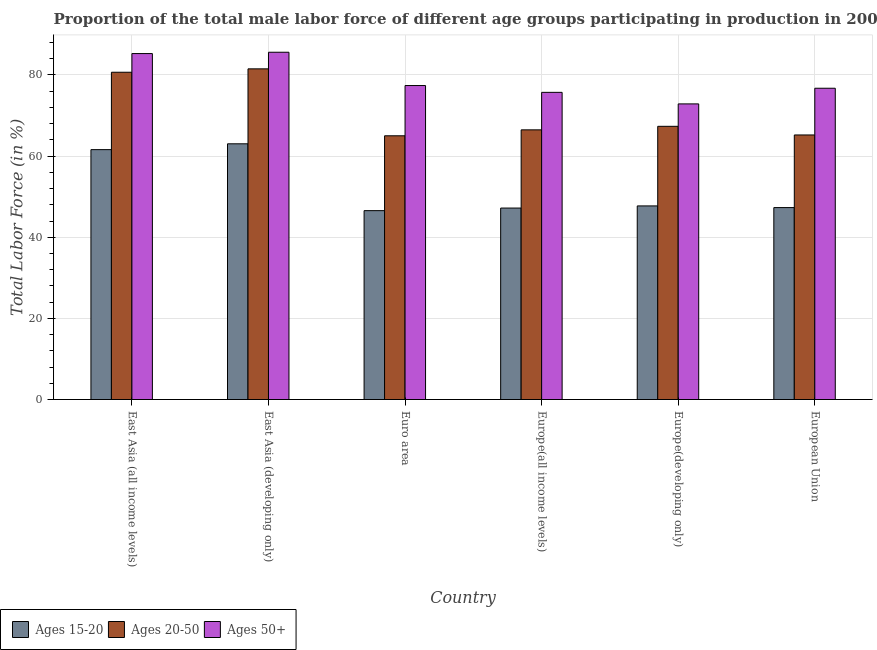How many different coloured bars are there?
Give a very brief answer. 3. How many groups of bars are there?
Offer a very short reply. 6. How many bars are there on the 3rd tick from the left?
Your answer should be very brief. 3. How many bars are there on the 6th tick from the right?
Make the answer very short. 3. What is the label of the 5th group of bars from the left?
Make the answer very short. Europe(developing only). What is the percentage of male labor force above age 50 in Europe(all income levels)?
Make the answer very short. 75.72. Across all countries, what is the maximum percentage of male labor force within the age group 15-20?
Your response must be concise. 63.04. Across all countries, what is the minimum percentage of male labor force within the age group 15-20?
Your answer should be compact. 46.56. In which country was the percentage of male labor force within the age group 15-20 maximum?
Keep it short and to the point. East Asia (developing only). In which country was the percentage of male labor force above age 50 minimum?
Offer a very short reply. Europe(developing only). What is the total percentage of male labor force above age 50 in the graph?
Provide a short and direct response. 473.61. What is the difference between the percentage of male labor force above age 50 in Euro area and that in European Union?
Your response must be concise. 0.67. What is the difference between the percentage of male labor force within the age group 15-20 in East Asia (developing only) and the percentage of male labor force within the age group 20-50 in European Union?
Ensure brevity in your answer.  -2.18. What is the average percentage of male labor force within the age group 20-50 per country?
Ensure brevity in your answer.  71.04. What is the difference between the percentage of male labor force within the age group 20-50 and percentage of male labor force above age 50 in European Union?
Your answer should be compact. -11.52. In how many countries, is the percentage of male labor force within the age group 20-50 greater than 32 %?
Your answer should be compact. 6. What is the ratio of the percentage of male labor force above age 50 in East Asia (developing only) to that in Euro area?
Offer a terse response. 1.11. Is the difference between the percentage of male labor force within the age group 20-50 in East Asia (developing only) and Europe(developing only) greater than the difference between the percentage of male labor force within the age group 15-20 in East Asia (developing only) and Europe(developing only)?
Your response must be concise. No. What is the difference between the highest and the second highest percentage of male labor force within the age group 15-20?
Offer a terse response. 1.44. What is the difference between the highest and the lowest percentage of male labor force within the age group 15-20?
Your answer should be compact. 16.48. In how many countries, is the percentage of male labor force within the age group 15-20 greater than the average percentage of male labor force within the age group 15-20 taken over all countries?
Provide a short and direct response. 2. What does the 3rd bar from the left in Europe(developing only) represents?
Your response must be concise. Ages 50+. What does the 1st bar from the right in East Asia (all income levels) represents?
Offer a very short reply. Ages 50+. How many bars are there?
Keep it short and to the point. 18. How many countries are there in the graph?
Keep it short and to the point. 6. Are the values on the major ticks of Y-axis written in scientific E-notation?
Keep it short and to the point. No. How many legend labels are there?
Give a very brief answer. 3. How are the legend labels stacked?
Your response must be concise. Horizontal. What is the title of the graph?
Offer a very short reply. Proportion of the total male labor force of different age groups participating in production in 2003. What is the label or title of the X-axis?
Your answer should be very brief. Country. What is the label or title of the Y-axis?
Provide a succinct answer. Total Labor Force (in %). What is the Total Labor Force (in %) of Ages 15-20 in East Asia (all income levels)?
Your answer should be compact. 61.6. What is the Total Labor Force (in %) in Ages 20-50 in East Asia (all income levels)?
Offer a very short reply. 80.68. What is the Total Labor Force (in %) in Ages 50+ in East Asia (all income levels)?
Ensure brevity in your answer.  85.28. What is the Total Labor Force (in %) in Ages 15-20 in East Asia (developing only)?
Your response must be concise. 63.04. What is the Total Labor Force (in %) of Ages 20-50 in East Asia (developing only)?
Your response must be concise. 81.51. What is the Total Labor Force (in %) in Ages 50+ in East Asia (developing only)?
Your answer should be very brief. 85.61. What is the Total Labor Force (in %) of Ages 15-20 in Euro area?
Give a very brief answer. 46.56. What is the Total Labor Force (in %) of Ages 20-50 in Euro area?
Your answer should be compact. 65.01. What is the Total Labor Force (in %) of Ages 50+ in Euro area?
Provide a short and direct response. 77.4. What is the Total Labor Force (in %) in Ages 15-20 in Europe(all income levels)?
Your answer should be compact. 47.2. What is the Total Labor Force (in %) of Ages 20-50 in Europe(all income levels)?
Your answer should be very brief. 66.48. What is the Total Labor Force (in %) in Ages 50+ in Europe(all income levels)?
Offer a very short reply. 75.72. What is the Total Labor Force (in %) of Ages 15-20 in Europe(developing only)?
Your response must be concise. 47.72. What is the Total Labor Force (in %) of Ages 20-50 in Europe(developing only)?
Offer a very short reply. 67.35. What is the Total Labor Force (in %) of Ages 50+ in Europe(developing only)?
Provide a succinct answer. 72.87. What is the Total Labor Force (in %) in Ages 15-20 in European Union?
Give a very brief answer. 47.31. What is the Total Labor Force (in %) of Ages 20-50 in European Union?
Offer a very short reply. 65.22. What is the Total Labor Force (in %) of Ages 50+ in European Union?
Offer a very short reply. 76.73. Across all countries, what is the maximum Total Labor Force (in %) of Ages 15-20?
Offer a terse response. 63.04. Across all countries, what is the maximum Total Labor Force (in %) in Ages 20-50?
Your response must be concise. 81.51. Across all countries, what is the maximum Total Labor Force (in %) in Ages 50+?
Offer a terse response. 85.61. Across all countries, what is the minimum Total Labor Force (in %) of Ages 15-20?
Provide a succinct answer. 46.56. Across all countries, what is the minimum Total Labor Force (in %) of Ages 20-50?
Keep it short and to the point. 65.01. Across all countries, what is the minimum Total Labor Force (in %) of Ages 50+?
Offer a terse response. 72.87. What is the total Total Labor Force (in %) of Ages 15-20 in the graph?
Offer a very short reply. 313.43. What is the total Total Labor Force (in %) in Ages 20-50 in the graph?
Keep it short and to the point. 426.25. What is the total Total Labor Force (in %) in Ages 50+ in the graph?
Provide a succinct answer. 473.61. What is the difference between the Total Labor Force (in %) of Ages 15-20 in East Asia (all income levels) and that in East Asia (developing only)?
Ensure brevity in your answer.  -1.44. What is the difference between the Total Labor Force (in %) of Ages 20-50 in East Asia (all income levels) and that in East Asia (developing only)?
Your answer should be compact. -0.84. What is the difference between the Total Labor Force (in %) of Ages 50+ in East Asia (all income levels) and that in East Asia (developing only)?
Provide a short and direct response. -0.33. What is the difference between the Total Labor Force (in %) of Ages 15-20 in East Asia (all income levels) and that in Euro area?
Make the answer very short. 15.04. What is the difference between the Total Labor Force (in %) in Ages 20-50 in East Asia (all income levels) and that in Euro area?
Ensure brevity in your answer.  15.67. What is the difference between the Total Labor Force (in %) of Ages 50+ in East Asia (all income levels) and that in Euro area?
Your answer should be very brief. 7.88. What is the difference between the Total Labor Force (in %) of Ages 15-20 in East Asia (all income levels) and that in Europe(all income levels)?
Give a very brief answer. 14.4. What is the difference between the Total Labor Force (in %) in Ages 20-50 in East Asia (all income levels) and that in Europe(all income levels)?
Give a very brief answer. 14.2. What is the difference between the Total Labor Force (in %) of Ages 50+ in East Asia (all income levels) and that in Europe(all income levels)?
Offer a terse response. 9.56. What is the difference between the Total Labor Force (in %) of Ages 15-20 in East Asia (all income levels) and that in Europe(developing only)?
Provide a short and direct response. 13.87. What is the difference between the Total Labor Force (in %) of Ages 20-50 in East Asia (all income levels) and that in Europe(developing only)?
Your response must be concise. 13.33. What is the difference between the Total Labor Force (in %) in Ages 50+ in East Asia (all income levels) and that in Europe(developing only)?
Offer a very short reply. 12.41. What is the difference between the Total Labor Force (in %) of Ages 15-20 in East Asia (all income levels) and that in European Union?
Provide a succinct answer. 14.29. What is the difference between the Total Labor Force (in %) of Ages 20-50 in East Asia (all income levels) and that in European Union?
Offer a terse response. 15.46. What is the difference between the Total Labor Force (in %) of Ages 50+ in East Asia (all income levels) and that in European Union?
Provide a succinct answer. 8.55. What is the difference between the Total Labor Force (in %) in Ages 15-20 in East Asia (developing only) and that in Euro area?
Offer a terse response. 16.48. What is the difference between the Total Labor Force (in %) in Ages 20-50 in East Asia (developing only) and that in Euro area?
Offer a very short reply. 16.5. What is the difference between the Total Labor Force (in %) in Ages 50+ in East Asia (developing only) and that in Euro area?
Your answer should be very brief. 8.21. What is the difference between the Total Labor Force (in %) in Ages 15-20 in East Asia (developing only) and that in Europe(all income levels)?
Ensure brevity in your answer.  15.84. What is the difference between the Total Labor Force (in %) in Ages 20-50 in East Asia (developing only) and that in Europe(all income levels)?
Provide a succinct answer. 15.04. What is the difference between the Total Labor Force (in %) in Ages 50+ in East Asia (developing only) and that in Europe(all income levels)?
Keep it short and to the point. 9.89. What is the difference between the Total Labor Force (in %) in Ages 15-20 in East Asia (developing only) and that in Europe(developing only)?
Offer a terse response. 15.31. What is the difference between the Total Labor Force (in %) in Ages 20-50 in East Asia (developing only) and that in Europe(developing only)?
Make the answer very short. 14.17. What is the difference between the Total Labor Force (in %) of Ages 50+ in East Asia (developing only) and that in Europe(developing only)?
Your answer should be very brief. 12.74. What is the difference between the Total Labor Force (in %) of Ages 15-20 in East Asia (developing only) and that in European Union?
Offer a very short reply. 15.72. What is the difference between the Total Labor Force (in %) of Ages 20-50 in East Asia (developing only) and that in European Union?
Your response must be concise. 16.3. What is the difference between the Total Labor Force (in %) in Ages 50+ in East Asia (developing only) and that in European Union?
Provide a short and direct response. 8.88. What is the difference between the Total Labor Force (in %) in Ages 15-20 in Euro area and that in Europe(all income levels)?
Ensure brevity in your answer.  -0.64. What is the difference between the Total Labor Force (in %) in Ages 20-50 in Euro area and that in Europe(all income levels)?
Offer a terse response. -1.46. What is the difference between the Total Labor Force (in %) in Ages 50+ in Euro area and that in Europe(all income levels)?
Give a very brief answer. 1.68. What is the difference between the Total Labor Force (in %) of Ages 15-20 in Euro area and that in Europe(developing only)?
Give a very brief answer. -1.17. What is the difference between the Total Labor Force (in %) in Ages 20-50 in Euro area and that in Europe(developing only)?
Provide a short and direct response. -2.34. What is the difference between the Total Labor Force (in %) of Ages 50+ in Euro area and that in Europe(developing only)?
Offer a terse response. 4.53. What is the difference between the Total Labor Force (in %) in Ages 15-20 in Euro area and that in European Union?
Your answer should be very brief. -0.76. What is the difference between the Total Labor Force (in %) in Ages 20-50 in Euro area and that in European Union?
Keep it short and to the point. -0.21. What is the difference between the Total Labor Force (in %) in Ages 50+ in Euro area and that in European Union?
Your answer should be compact. 0.67. What is the difference between the Total Labor Force (in %) in Ages 15-20 in Europe(all income levels) and that in Europe(developing only)?
Offer a very short reply. -0.53. What is the difference between the Total Labor Force (in %) in Ages 20-50 in Europe(all income levels) and that in Europe(developing only)?
Make the answer very short. -0.87. What is the difference between the Total Labor Force (in %) in Ages 50+ in Europe(all income levels) and that in Europe(developing only)?
Make the answer very short. 2.85. What is the difference between the Total Labor Force (in %) of Ages 15-20 in Europe(all income levels) and that in European Union?
Offer a terse response. -0.12. What is the difference between the Total Labor Force (in %) of Ages 20-50 in Europe(all income levels) and that in European Union?
Make the answer very short. 1.26. What is the difference between the Total Labor Force (in %) of Ages 50+ in Europe(all income levels) and that in European Union?
Offer a terse response. -1.01. What is the difference between the Total Labor Force (in %) of Ages 15-20 in Europe(developing only) and that in European Union?
Your answer should be compact. 0.41. What is the difference between the Total Labor Force (in %) in Ages 20-50 in Europe(developing only) and that in European Union?
Make the answer very short. 2.13. What is the difference between the Total Labor Force (in %) in Ages 50+ in Europe(developing only) and that in European Union?
Your answer should be compact. -3.86. What is the difference between the Total Labor Force (in %) of Ages 15-20 in East Asia (all income levels) and the Total Labor Force (in %) of Ages 20-50 in East Asia (developing only)?
Ensure brevity in your answer.  -19.91. What is the difference between the Total Labor Force (in %) in Ages 15-20 in East Asia (all income levels) and the Total Labor Force (in %) in Ages 50+ in East Asia (developing only)?
Give a very brief answer. -24.01. What is the difference between the Total Labor Force (in %) in Ages 20-50 in East Asia (all income levels) and the Total Labor Force (in %) in Ages 50+ in East Asia (developing only)?
Ensure brevity in your answer.  -4.93. What is the difference between the Total Labor Force (in %) of Ages 15-20 in East Asia (all income levels) and the Total Labor Force (in %) of Ages 20-50 in Euro area?
Make the answer very short. -3.41. What is the difference between the Total Labor Force (in %) in Ages 15-20 in East Asia (all income levels) and the Total Labor Force (in %) in Ages 50+ in Euro area?
Provide a succinct answer. -15.8. What is the difference between the Total Labor Force (in %) in Ages 20-50 in East Asia (all income levels) and the Total Labor Force (in %) in Ages 50+ in Euro area?
Ensure brevity in your answer.  3.28. What is the difference between the Total Labor Force (in %) of Ages 15-20 in East Asia (all income levels) and the Total Labor Force (in %) of Ages 20-50 in Europe(all income levels)?
Keep it short and to the point. -4.88. What is the difference between the Total Labor Force (in %) in Ages 15-20 in East Asia (all income levels) and the Total Labor Force (in %) in Ages 50+ in Europe(all income levels)?
Your response must be concise. -14.12. What is the difference between the Total Labor Force (in %) in Ages 20-50 in East Asia (all income levels) and the Total Labor Force (in %) in Ages 50+ in Europe(all income levels)?
Your answer should be very brief. 4.96. What is the difference between the Total Labor Force (in %) in Ages 15-20 in East Asia (all income levels) and the Total Labor Force (in %) in Ages 20-50 in Europe(developing only)?
Give a very brief answer. -5.75. What is the difference between the Total Labor Force (in %) of Ages 15-20 in East Asia (all income levels) and the Total Labor Force (in %) of Ages 50+ in Europe(developing only)?
Give a very brief answer. -11.27. What is the difference between the Total Labor Force (in %) in Ages 20-50 in East Asia (all income levels) and the Total Labor Force (in %) in Ages 50+ in Europe(developing only)?
Offer a very short reply. 7.81. What is the difference between the Total Labor Force (in %) of Ages 15-20 in East Asia (all income levels) and the Total Labor Force (in %) of Ages 20-50 in European Union?
Your answer should be very brief. -3.62. What is the difference between the Total Labor Force (in %) in Ages 15-20 in East Asia (all income levels) and the Total Labor Force (in %) in Ages 50+ in European Union?
Your answer should be very brief. -15.13. What is the difference between the Total Labor Force (in %) in Ages 20-50 in East Asia (all income levels) and the Total Labor Force (in %) in Ages 50+ in European Union?
Offer a very short reply. 3.95. What is the difference between the Total Labor Force (in %) of Ages 15-20 in East Asia (developing only) and the Total Labor Force (in %) of Ages 20-50 in Euro area?
Make the answer very short. -1.98. What is the difference between the Total Labor Force (in %) of Ages 15-20 in East Asia (developing only) and the Total Labor Force (in %) of Ages 50+ in Euro area?
Your answer should be very brief. -14.36. What is the difference between the Total Labor Force (in %) in Ages 20-50 in East Asia (developing only) and the Total Labor Force (in %) in Ages 50+ in Euro area?
Ensure brevity in your answer.  4.12. What is the difference between the Total Labor Force (in %) in Ages 15-20 in East Asia (developing only) and the Total Labor Force (in %) in Ages 20-50 in Europe(all income levels)?
Your response must be concise. -3.44. What is the difference between the Total Labor Force (in %) in Ages 15-20 in East Asia (developing only) and the Total Labor Force (in %) in Ages 50+ in Europe(all income levels)?
Your answer should be compact. -12.68. What is the difference between the Total Labor Force (in %) in Ages 20-50 in East Asia (developing only) and the Total Labor Force (in %) in Ages 50+ in Europe(all income levels)?
Your answer should be compact. 5.79. What is the difference between the Total Labor Force (in %) of Ages 15-20 in East Asia (developing only) and the Total Labor Force (in %) of Ages 20-50 in Europe(developing only)?
Ensure brevity in your answer.  -4.31. What is the difference between the Total Labor Force (in %) of Ages 15-20 in East Asia (developing only) and the Total Labor Force (in %) of Ages 50+ in Europe(developing only)?
Provide a succinct answer. -9.84. What is the difference between the Total Labor Force (in %) of Ages 20-50 in East Asia (developing only) and the Total Labor Force (in %) of Ages 50+ in Europe(developing only)?
Keep it short and to the point. 8.64. What is the difference between the Total Labor Force (in %) in Ages 15-20 in East Asia (developing only) and the Total Labor Force (in %) in Ages 20-50 in European Union?
Offer a terse response. -2.18. What is the difference between the Total Labor Force (in %) of Ages 15-20 in East Asia (developing only) and the Total Labor Force (in %) of Ages 50+ in European Union?
Make the answer very short. -13.7. What is the difference between the Total Labor Force (in %) in Ages 20-50 in East Asia (developing only) and the Total Labor Force (in %) in Ages 50+ in European Union?
Your response must be concise. 4.78. What is the difference between the Total Labor Force (in %) of Ages 15-20 in Euro area and the Total Labor Force (in %) of Ages 20-50 in Europe(all income levels)?
Provide a succinct answer. -19.92. What is the difference between the Total Labor Force (in %) in Ages 15-20 in Euro area and the Total Labor Force (in %) in Ages 50+ in Europe(all income levels)?
Provide a short and direct response. -29.16. What is the difference between the Total Labor Force (in %) in Ages 20-50 in Euro area and the Total Labor Force (in %) in Ages 50+ in Europe(all income levels)?
Offer a very short reply. -10.71. What is the difference between the Total Labor Force (in %) of Ages 15-20 in Euro area and the Total Labor Force (in %) of Ages 20-50 in Europe(developing only)?
Provide a succinct answer. -20.79. What is the difference between the Total Labor Force (in %) in Ages 15-20 in Euro area and the Total Labor Force (in %) in Ages 50+ in Europe(developing only)?
Your response must be concise. -26.31. What is the difference between the Total Labor Force (in %) in Ages 20-50 in Euro area and the Total Labor Force (in %) in Ages 50+ in Europe(developing only)?
Ensure brevity in your answer.  -7.86. What is the difference between the Total Labor Force (in %) in Ages 15-20 in Euro area and the Total Labor Force (in %) in Ages 20-50 in European Union?
Keep it short and to the point. -18.66. What is the difference between the Total Labor Force (in %) in Ages 15-20 in Euro area and the Total Labor Force (in %) in Ages 50+ in European Union?
Make the answer very short. -30.17. What is the difference between the Total Labor Force (in %) of Ages 20-50 in Euro area and the Total Labor Force (in %) of Ages 50+ in European Union?
Provide a short and direct response. -11.72. What is the difference between the Total Labor Force (in %) of Ages 15-20 in Europe(all income levels) and the Total Labor Force (in %) of Ages 20-50 in Europe(developing only)?
Keep it short and to the point. -20.15. What is the difference between the Total Labor Force (in %) in Ages 15-20 in Europe(all income levels) and the Total Labor Force (in %) in Ages 50+ in Europe(developing only)?
Your answer should be very brief. -25.67. What is the difference between the Total Labor Force (in %) in Ages 20-50 in Europe(all income levels) and the Total Labor Force (in %) in Ages 50+ in Europe(developing only)?
Provide a succinct answer. -6.4. What is the difference between the Total Labor Force (in %) of Ages 15-20 in Europe(all income levels) and the Total Labor Force (in %) of Ages 20-50 in European Union?
Offer a very short reply. -18.02. What is the difference between the Total Labor Force (in %) of Ages 15-20 in Europe(all income levels) and the Total Labor Force (in %) of Ages 50+ in European Union?
Your answer should be very brief. -29.53. What is the difference between the Total Labor Force (in %) in Ages 20-50 in Europe(all income levels) and the Total Labor Force (in %) in Ages 50+ in European Union?
Make the answer very short. -10.26. What is the difference between the Total Labor Force (in %) of Ages 15-20 in Europe(developing only) and the Total Labor Force (in %) of Ages 20-50 in European Union?
Make the answer very short. -17.49. What is the difference between the Total Labor Force (in %) of Ages 15-20 in Europe(developing only) and the Total Labor Force (in %) of Ages 50+ in European Union?
Your response must be concise. -29.01. What is the difference between the Total Labor Force (in %) of Ages 20-50 in Europe(developing only) and the Total Labor Force (in %) of Ages 50+ in European Union?
Your answer should be very brief. -9.39. What is the average Total Labor Force (in %) of Ages 15-20 per country?
Provide a short and direct response. 52.24. What is the average Total Labor Force (in %) of Ages 20-50 per country?
Your answer should be very brief. 71.04. What is the average Total Labor Force (in %) of Ages 50+ per country?
Your answer should be very brief. 78.94. What is the difference between the Total Labor Force (in %) of Ages 15-20 and Total Labor Force (in %) of Ages 20-50 in East Asia (all income levels)?
Your answer should be very brief. -19.08. What is the difference between the Total Labor Force (in %) in Ages 15-20 and Total Labor Force (in %) in Ages 50+ in East Asia (all income levels)?
Keep it short and to the point. -23.68. What is the difference between the Total Labor Force (in %) of Ages 20-50 and Total Labor Force (in %) of Ages 50+ in East Asia (all income levels)?
Provide a short and direct response. -4.6. What is the difference between the Total Labor Force (in %) in Ages 15-20 and Total Labor Force (in %) in Ages 20-50 in East Asia (developing only)?
Your answer should be compact. -18.48. What is the difference between the Total Labor Force (in %) of Ages 15-20 and Total Labor Force (in %) of Ages 50+ in East Asia (developing only)?
Give a very brief answer. -22.57. What is the difference between the Total Labor Force (in %) in Ages 20-50 and Total Labor Force (in %) in Ages 50+ in East Asia (developing only)?
Offer a terse response. -4.09. What is the difference between the Total Labor Force (in %) of Ages 15-20 and Total Labor Force (in %) of Ages 20-50 in Euro area?
Your answer should be compact. -18.45. What is the difference between the Total Labor Force (in %) in Ages 15-20 and Total Labor Force (in %) in Ages 50+ in Euro area?
Ensure brevity in your answer.  -30.84. What is the difference between the Total Labor Force (in %) in Ages 20-50 and Total Labor Force (in %) in Ages 50+ in Euro area?
Your answer should be compact. -12.39. What is the difference between the Total Labor Force (in %) of Ages 15-20 and Total Labor Force (in %) of Ages 20-50 in Europe(all income levels)?
Give a very brief answer. -19.28. What is the difference between the Total Labor Force (in %) of Ages 15-20 and Total Labor Force (in %) of Ages 50+ in Europe(all income levels)?
Your answer should be very brief. -28.52. What is the difference between the Total Labor Force (in %) of Ages 20-50 and Total Labor Force (in %) of Ages 50+ in Europe(all income levels)?
Offer a terse response. -9.24. What is the difference between the Total Labor Force (in %) of Ages 15-20 and Total Labor Force (in %) of Ages 20-50 in Europe(developing only)?
Keep it short and to the point. -19.62. What is the difference between the Total Labor Force (in %) of Ages 15-20 and Total Labor Force (in %) of Ages 50+ in Europe(developing only)?
Offer a terse response. -25.15. What is the difference between the Total Labor Force (in %) of Ages 20-50 and Total Labor Force (in %) of Ages 50+ in Europe(developing only)?
Offer a very short reply. -5.53. What is the difference between the Total Labor Force (in %) of Ages 15-20 and Total Labor Force (in %) of Ages 20-50 in European Union?
Keep it short and to the point. -17.9. What is the difference between the Total Labor Force (in %) in Ages 15-20 and Total Labor Force (in %) in Ages 50+ in European Union?
Offer a very short reply. -29.42. What is the difference between the Total Labor Force (in %) in Ages 20-50 and Total Labor Force (in %) in Ages 50+ in European Union?
Make the answer very short. -11.52. What is the ratio of the Total Labor Force (in %) of Ages 15-20 in East Asia (all income levels) to that in East Asia (developing only)?
Provide a succinct answer. 0.98. What is the ratio of the Total Labor Force (in %) of Ages 20-50 in East Asia (all income levels) to that in East Asia (developing only)?
Provide a short and direct response. 0.99. What is the ratio of the Total Labor Force (in %) in Ages 50+ in East Asia (all income levels) to that in East Asia (developing only)?
Offer a terse response. 1. What is the ratio of the Total Labor Force (in %) in Ages 15-20 in East Asia (all income levels) to that in Euro area?
Give a very brief answer. 1.32. What is the ratio of the Total Labor Force (in %) of Ages 20-50 in East Asia (all income levels) to that in Euro area?
Your answer should be compact. 1.24. What is the ratio of the Total Labor Force (in %) of Ages 50+ in East Asia (all income levels) to that in Euro area?
Ensure brevity in your answer.  1.1. What is the ratio of the Total Labor Force (in %) of Ages 15-20 in East Asia (all income levels) to that in Europe(all income levels)?
Offer a terse response. 1.31. What is the ratio of the Total Labor Force (in %) in Ages 20-50 in East Asia (all income levels) to that in Europe(all income levels)?
Offer a very short reply. 1.21. What is the ratio of the Total Labor Force (in %) of Ages 50+ in East Asia (all income levels) to that in Europe(all income levels)?
Provide a short and direct response. 1.13. What is the ratio of the Total Labor Force (in %) in Ages 15-20 in East Asia (all income levels) to that in Europe(developing only)?
Your response must be concise. 1.29. What is the ratio of the Total Labor Force (in %) in Ages 20-50 in East Asia (all income levels) to that in Europe(developing only)?
Your answer should be compact. 1.2. What is the ratio of the Total Labor Force (in %) in Ages 50+ in East Asia (all income levels) to that in Europe(developing only)?
Ensure brevity in your answer.  1.17. What is the ratio of the Total Labor Force (in %) of Ages 15-20 in East Asia (all income levels) to that in European Union?
Give a very brief answer. 1.3. What is the ratio of the Total Labor Force (in %) in Ages 20-50 in East Asia (all income levels) to that in European Union?
Provide a succinct answer. 1.24. What is the ratio of the Total Labor Force (in %) in Ages 50+ in East Asia (all income levels) to that in European Union?
Make the answer very short. 1.11. What is the ratio of the Total Labor Force (in %) of Ages 15-20 in East Asia (developing only) to that in Euro area?
Your answer should be very brief. 1.35. What is the ratio of the Total Labor Force (in %) of Ages 20-50 in East Asia (developing only) to that in Euro area?
Keep it short and to the point. 1.25. What is the ratio of the Total Labor Force (in %) in Ages 50+ in East Asia (developing only) to that in Euro area?
Your answer should be compact. 1.11. What is the ratio of the Total Labor Force (in %) in Ages 15-20 in East Asia (developing only) to that in Europe(all income levels)?
Provide a short and direct response. 1.34. What is the ratio of the Total Labor Force (in %) in Ages 20-50 in East Asia (developing only) to that in Europe(all income levels)?
Offer a very short reply. 1.23. What is the ratio of the Total Labor Force (in %) in Ages 50+ in East Asia (developing only) to that in Europe(all income levels)?
Give a very brief answer. 1.13. What is the ratio of the Total Labor Force (in %) of Ages 15-20 in East Asia (developing only) to that in Europe(developing only)?
Offer a terse response. 1.32. What is the ratio of the Total Labor Force (in %) of Ages 20-50 in East Asia (developing only) to that in Europe(developing only)?
Your answer should be compact. 1.21. What is the ratio of the Total Labor Force (in %) of Ages 50+ in East Asia (developing only) to that in Europe(developing only)?
Your response must be concise. 1.17. What is the ratio of the Total Labor Force (in %) in Ages 15-20 in East Asia (developing only) to that in European Union?
Make the answer very short. 1.33. What is the ratio of the Total Labor Force (in %) in Ages 20-50 in East Asia (developing only) to that in European Union?
Keep it short and to the point. 1.25. What is the ratio of the Total Labor Force (in %) of Ages 50+ in East Asia (developing only) to that in European Union?
Offer a terse response. 1.12. What is the ratio of the Total Labor Force (in %) of Ages 15-20 in Euro area to that in Europe(all income levels)?
Provide a succinct answer. 0.99. What is the ratio of the Total Labor Force (in %) in Ages 20-50 in Euro area to that in Europe(all income levels)?
Provide a short and direct response. 0.98. What is the ratio of the Total Labor Force (in %) in Ages 50+ in Euro area to that in Europe(all income levels)?
Your answer should be compact. 1.02. What is the ratio of the Total Labor Force (in %) in Ages 15-20 in Euro area to that in Europe(developing only)?
Provide a short and direct response. 0.98. What is the ratio of the Total Labor Force (in %) of Ages 20-50 in Euro area to that in Europe(developing only)?
Provide a short and direct response. 0.97. What is the ratio of the Total Labor Force (in %) in Ages 50+ in Euro area to that in Europe(developing only)?
Your answer should be compact. 1.06. What is the ratio of the Total Labor Force (in %) in Ages 20-50 in Euro area to that in European Union?
Ensure brevity in your answer.  1. What is the ratio of the Total Labor Force (in %) of Ages 50+ in Euro area to that in European Union?
Make the answer very short. 1.01. What is the ratio of the Total Labor Force (in %) of Ages 15-20 in Europe(all income levels) to that in Europe(developing only)?
Make the answer very short. 0.99. What is the ratio of the Total Labor Force (in %) in Ages 20-50 in Europe(all income levels) to that in Europe(developing only)?
Give a very brief answer. 0.99. What is the ratio of the Total Labor Force (in %) in Ages 50+ in Europe(all income levels) to that in Europe(developing only)?
Your answer should be very brief. 1.04. What is the ratio of the Total Labor Force (in %) of Ages 20-50 in Europe(all income levels) to that in European Union?
Provide a short and direct response. 1.02. What is the ratio of the Total Labor Force (in %) in Ages 50+ in Europe(all income levels) to that in European Union?
Make the answer very short. 0.99. What is the ratio of the Total Labor Force (in %) of Ages 15-20 in Europe(developing only) to that in European Union?
Offer a terse response. 1.01. What is the ratio of the Total Labor Force (in %) of Ages 20-50 in Europe(developing only) to that in European Union?
Keep it short and to the point. 1.03. What is the ratio of the Total Labor Force (in %) in Ages 50+ in Europe(developing only) to that in European Union?
Keep it short and to the point. 0.95. What is the difference between the highest and the second highest Total Labor Force (in %) in Ages 15-20?
Give a very brief answer. 1.44. What is the difference between the highest and the second highest Total Labor Force (in %) in Ages 20-50?
Give a very brief answer. 0.84. What is the difference between the highest and the second highest Total Labor Force (in %) of Ages 50+?
Your response must be concise. 0.33. What is the difference between the highest and the lowest Total Labor Force (in %) of Ages 15-20?
Your response must be concise. 16.48. What is the difference between the highest and the lowest Total Labor Force (in %) of Ages 20-50?
Keep it short and to the point. 16.5. What is the difference between the highest and the lowest Total Labor Force (in %) in Ages 50+?
Make the answer very short. 12.74. 